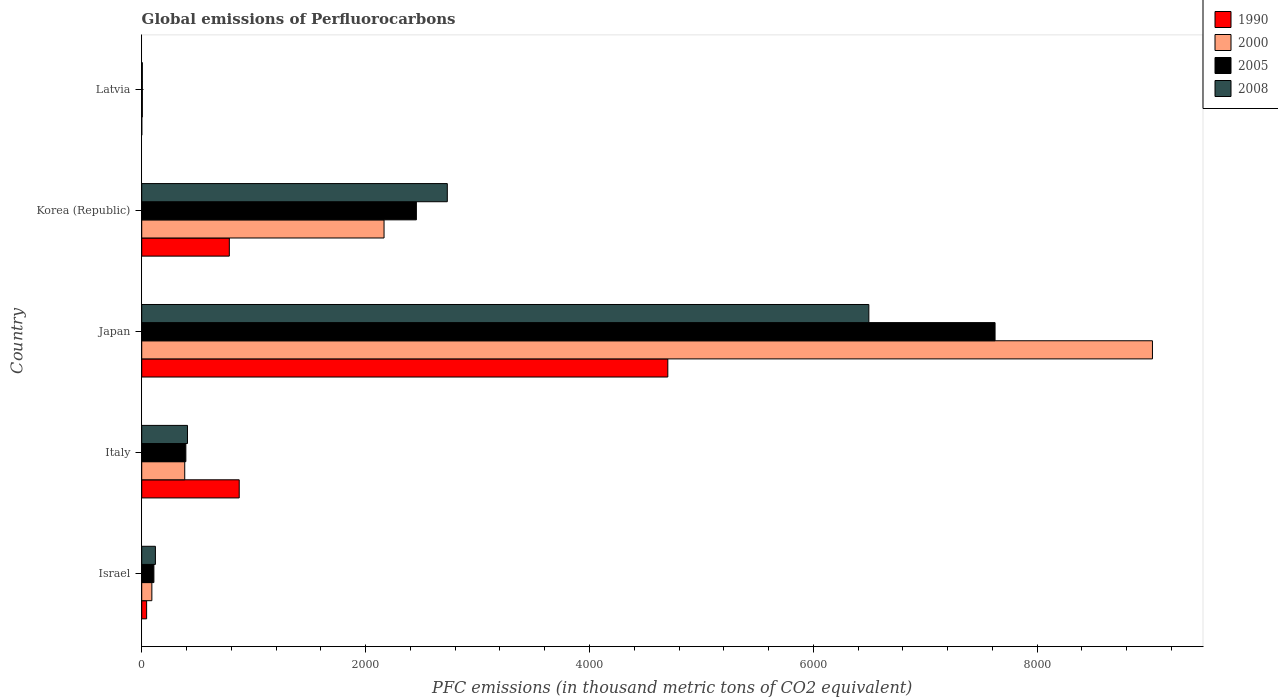How many different coloured bars are there?
Make the answer very short. 4. How many groups of bars are there?
Your answer should be very brief. 5. Are the number of bars per tick equal to the number of legend labels?
Your answer should be very brief. Yes. How many bars are there on the 3rd tick from the bottom?
Make the answer very short. 4. What is the label of the 5th group of bars from the top?
Offer a terse response. Israel. In how many cases, is the number of bars for a given country not equal to the number of legend labels?
Your response must be concise. 0. What is the global emissions of Perfluorocarbons in 2008 in Japan?
Your answer should be compact. 6496.1. Across all countries, what is the maximum global emissions of Perfluorocarbons in 2005?
Provide a succinct answer. 7623.6. Across all countries, what is the minimum global emissions of Perfluorocarbons in 2005?
Keep it short and to the point. 5.5. In which country was the global emissions of Perfluorocarbons in 1990 maximum?
Your answer should be compact. Japan. In which country was the global emissions of Perfluorocarbons in 2008 minimum?
Ensure brevity in your answer.  Latvia. What is the total global emissions of Perfluorocarbons in 1990 in the graph?
Keep it short and to the point. 6398.1. What is the difference between the global emissions of Perfluorocarbons in 2005 in Israel and that in Latvia?
Provide a short and direct response. 103.2. What is the difference between the global emissions of Perfluorocarbons in 1990 in Japan and the global emissions of Perfluorocarbons in 2008 in Italy?
Offer a terse response. 4291.2. What is the average global emissions of Perfluorocarbons in 1990 per country?
Provide a short and direct response. 1279.62. What is the difference between the global emissions of Perfluorocarbons in 2005 and global emissions of Perfluorocarbons in 1990 in Latvia?
Ensure brevity in your answer.  4.8. What is the ratio of the global emissions of Perfluorocarbons in 1990 in Israel to that in Japan?
Give a very brief answer. 0.01. Is the global emissions of Perfluorocarbons in 2005 in Israel less than that in Latvia?
Give a very brief answer. No. What is the difference between the highest and the second highest global emissions of Perfluorocarbons in 2005?
Offer a very short reply. 5169.9. What is the difference between the highest and the lowest global emissions of Perfluorocarbons in 2005?
Ensure brevity in your answer.  7618.1. Is it the case that in every country, the sum of the global emissions of Perfluorocarbons in 2008 and global emissions of Perfluorocarbons in 2000 is greater than the sum of global emissions of Perfluorocarbons in 1990 and global emissions of Perfluorocarbons in 2005?
Your answer should be very brief. No. What does the 3rd bar from the top in Latvia represents?
Provide a succinct answer. 2000. What does the 4th bar from the bottom in Italy represents?
Your response must be concise. 2008. Are the values on the major ticks of X-axis written in scientific E-notation?
Offer a terse response. No. Does the graph contain any zero values?
Make the answer very short. No. Does the graph contain grids?
Offer a very short reply. No. How are the legend labels stacked?
Ensure brevity in your answer.  Vertical. What is the title of the graph?
Your answer should be compact. Global emissions of Perfluorocarbons. Does "2004" appear as one of the legend labels in the graph?
Give a very brief answer. No. What is the label or title of the X-axis?
Offer a terse response. PFC emissions (in thousand metric tons of CO2 equivalent). What is the PFC emissions (in thousand metric tons of CO2 equivalent) in 1990 in Israel?
Provide a short and direct response. 43.8. What is the PFC emissions (in thousand metric tons of CO2 equivalent) in 2000 in Israel?
Provide a short and direct response. 90.5. What is the PFC emissions (in thousand metric tons of CO2 equivalent) of 2005 in Israel?
Keep it short and to the point. 108.7. What is the PFC emissions (in thousand metric tons of CO2 equivalent) of 2008 in Israel?
Provide a succinct answer. 122.3. What is the PFC emissions (in thousand metric tons of CO2 equivalent) in 1990 in Italy?
Make the answer very short. 871. What is the PFC emissions (in thousand metric tons of CO2 equivalent) of 2000 in Italy?
Give a very brief answer. 384.3. What is the PFC emissions (in thousand metric tons of CO2 equivalent) of 2005 in Italy?
Make the answer very short. 394.3. What is the PFC emissions (in thousand metric tons of CO2 equivalent) in 2008 in Italy?
Give a very brief answer. 408.8. What is the PFC emissions (in thousand metric tons of CO2 equivalent) of 1990 in Japan?
Provide a short and direct response. 4700. What is the PFC emissions (in thousand metric tons of CO2 equivalent) of 2000 in Japan?
Ensure brevity in your answer.  9029.8. What is the PFC emissions (in thousand metric tons of CO2 equivalent) in 2005 in Japan?
Your answer should be compact. 7623.6. What is the PFC emissions (in thousand metric tons of CO2 equivalent) in 2008 in Japan?
Provide a short and direct response. 6496.1. What is the PFC emissions (in thousand metric tons of CO2 equivalent) in 1990 in Korea (Republic)?
Offer a terse response. 782.6. What is the PFC emissions (in thousand metric tons of CO2 equivalent) of 2000 in Korea (Republic)?
Your response must be concise. 2164.9. What is the PFC emissions (in thousand metric tons of CO2 equivalent) of 2005 in Korea (Republic)?
Make the answer very short. 2453.7. What is the PFC emissions (in thousand metric tons of CO2 equivalent) in 2008 in Korea (Republic)?
Your answer should be very brief. 2730.1. What is the PFC emissions (in thousand metric tons of CO2 equivalent) of 2000 in Latvia?
Offer a very short reply. 5.7. Across all countries, what is the maximum PFC emissions (in thousand metric tons of CO2 equivalent) in 1990?
Offer a terse response. 4700. Across all countries, what is the maximum PFC emissions (in thousand metric tons of CO2 equivalent) of 2000?
Offer a very short reply. 9029.8. Across all countries, what is the maximum PFC emissions (in thousand metric tons of CO2 equivalent) in 2005?
Give a very brief answer. 7623.6. Across all countries, what is the maximum PFC emissions (in thousand metric tons of CO2 equivalent) of 2008?
Give a very brief answer. 6496.1. Across all countries, what is the minimum PFC emissions (in thousand metric tons of CO2 equivalent) of 1990?
Offer a very short reply. 0.7. Across all countries, what is the minimum PFC emissions (in thousand metric tons of CO2 equivalent) in 2000?
Ensure brevity in your answer.  5.7. Across all countries, what is the minimum PFC emissions (in thousand metric tons of CO2 equivalent) in 2005?
Keep it short and to the point. 5.5. What is the total PFC emissions (in thousand metric tons of CO2 equivalent) of 1990 in the graph?
Offer a terse response. 6398.1. What is the total PFC emissions (in thousand metric tons of CO2 equivalent) of 2000 in the graph?
Provide a succinct answer. 1.17e+04. What is the total PFC emissions (in thousand metric tons of CO2 equivalent) in 2005 in the graph?
Make the answer very short. 1.06e+04. What is the total PFC emissions (in thousand metric tons of CO2 equivalent) of 2008 in the graph?
Provide a succinct answer. 9762.8. What is the difference between the PFC emissions (in thousand metric tons of CO2 equivalent) in 1990 in Israel and that in Italy?
Provide a succinct answer. -827.2. What is the difference between the PFC emissions (in thousand metric tons of CO2 equivalent) in 2000 in Israel and that in Italy?
Your answer should be compact. -293.8. What is the difference between the PFC emissions (in thousand metric tons of CO2 equivalent) of 2005 in Israel and that in Italy?
Give a very brief answer. -285.6. What is the difference between the PFC emissions (in thousand metric tons of CO2 equivalent) of 2008 in Israel and that in Italy?
Keep it short and to the point. -286.5. What is the difference between the PFC emissions (in thousand metric tons of CO2 equivalent) of 1990 in Israel and that in Japan?
Provide a succinct answer. -4656.2. What is the difference between the PFC emissions (in thousand metric tons of CO2 equivalent) in 2000 in Israel and that in Japan?
Provide a short and direct response. -8939.3. What is the difference between the PFC emissions (in thousand metric tons of CO2 equivalent) in 2005 in Israel and that in Japan?
Offer a very short reply. -7514.9. What is the difference between the PFC emissions (in thousand metric tons of CO2 equivalent) in 2008 in Israel and that in Japan?
Give a very brief answer. -6373.8. What is the difference between the PFC emissions (in thousand metric tons of CO2 equivalent) of 1990 in Israel and that in Korea (Republic)?
Ensure brevity in your answer.  -738.8. What is the difference between the PFC emissions (in thousand metric tons of CO2 equivalent) of 2000 in Israel and that in Korea (Republic)?
Offer a very short reply. -2074.4. What is the difference between the PFC emissions (in thousand metric tons of CO2 equivalent) of 2005 in Israel and that in Korea (Republic)?
Provide a succinct answer. -2345. What is the difference between the PFC emissions (in thousand metric tons of CO2 equivalent) in 2008 in Israel and that in Korea (Republic)?
Your answer should be very brief. -2607.8. What is the difference between the PFC emissions (in thousand metric tons of CO2 equivalent) of 1990 in Israel and that in Latvia?
Your answer should be very brief. 43.1. What is the difference between the PFC emissions (in thousand metric tons of CO2 equivalent) in 2000 in Israel and that in Latvia?
Offer a terse response. 84.8. What is the difference between the PFC emissions (in thousand metric tons of CO2 equivalent) in 2005 in Israel and that in Latvia?
Your answer should be compact. 103.2. What is the difference between the PFC emissions (in thousand metric tons of CO2 equivalent) of 2008 in Israel and that in Latvia?
Give a very brief answer. 116.8. What is the difference between the PFC emissions (in thousand metric tons of CO2 equivalent) in 1990 in Italy and that in Japan?
Offer a very short reply. -3829. What is the difference between the PFC emissions (in thousand metric tons of CO2 equivalent) of 2000 in Italy and that in Japan?
Your response must be concise. -8645.5. What is the difference between the PFC emissions (in thousand metric tons of CO2 equivalent) in 2005 in Italy and that in Japan?
Give a very brief answer. -7229.3. What is the difference between the PFC emissions (in thousand metric tons of CO2 equivalent) of 2008 in Italy and that in Japan?
Offer a very short reply. -6087.3. What is the difference between the PFC emissions (in thousand metric tons of CO2 equivalent) of 1990 in Italy and that in Korea (Republic)?
Your response must be concise. 88.4. What is the difference between the PFC emissions (in thousand metric tons of CO2 equivalent) in 2000 in Italy and that in Korea (Republic)?
Your answer should be compact. -1780.6. What is the difference between the PFC emissions (in thousand metric tons of CO2 equivalent) in 2005 in Italy and that in Korea (Republic)?
Your answer should be compact. -2059.4. What is the difference between the PFC emissions (in thousand metric tons of CO2 equivalent) of 2008 in Italy and that in Korea (Republic)?
Offer a terse response. -2321.3. What is the difference between the PFC emissions (in thousand metric tons of CO2 equivalent) of 1990 in Italy and that in Latvia?
Offer a terse response. 870.3. What is the difference between the PFC emissions (in thousand metric tons of CO2 equivalent) in 2000 in Italy and that in Latvia?
Your response must be concise. 378.6. What is the difference between the PFC emissions (in thousand metric tons of CO2 equivalent) in 2005 in Italy and that in Latvia?
Offer a terse response. 388.8. What is the difference between the PFC emissions (in thousand metric tons of CO2 equivalent) of 2008 in Italy and that in Latvia?
Your response must be concise. 403.3. What is the difference between the PFC emissions (in thousand metric tons of CO2 equivalent) of 1990 in Japan and that in Korea (Republic)?
Offer a very short reply. 3917.4. What is the difference between the PFC emissions (in thousand metric tons of CO2 equivalent) of 2000 in Japan and that in Korea (Republic)?
Ensure brevity in your answer.  6864.9. What is the difference between the PFC emissions (in thousand metric tons of CO2 equivalent) of 2005 in Japan and that in Korea (Republic)?
Your response must be concise. 5169.9. What is the difference between the PFC emissions (in thousand metric tons of CO2 equivalent) in 2008 in Japan and that in Korea (Republic)?
Offer a terse response. 3766. What is the difference between the PFC emissions (in thousand metric tons of CO2 equivalent) in 1990 in Japan and that in Latvia?
Make the answer very short. 4699.3. What is the difference between the PFC emissions (in thousand metric tons of CO2 equivalent) of 2000 in Japan and that in Latvia?
Ensure brevity in your answer.  9024.1. What is the difference between the PFC emissions (in thousand metric tons of CO2 equivalent) of 2005 in Japan and that in Latvia?
Give a very brief answer. 7618.1. What is the difference between the PFC emissions (in thousand metric tons of CO2 equivalent) of 2008 in Japan and that in Latvia?
Make the answer very short. 6490.6. What is the difference between the PFC emissions (in thousand metric tons of CO2 equivalent) in 1990 in Korea (Republic) and that in Latvia?
Offer a terse response. 781.9. What is the difference between the PFC emissions (in thousand metric tons of CO2 equivalent) in 2000 in Korea (Republic) and that in Latvia?
Offer a very short reply. 2159.2. What is the difference between the PFC emissions (in thousand metric tons of CO2 equivalent) of 2005 in Korea (Republic) and that in Latvia?
Offer a terse response. 2448.2. What is the difference between the PFC emissions (in thousand metric tons of CO2 equivalent) of 2008 in Korea (Republic) and that in Latvia?
Provide a succinct answer. 2724.6. What is the difference between the PFC emissions (in thousand metric tons of CO2 equivalent) in 1990 in Israel and the PFC emissions (in thousand metric tons of CO2 equivalent) in 2000 in Italy?
Provide a short and direct response. -340.5. What is the difference between the PFC emissions (in thousand metric tons of CO2 equivalent) in 1990 in Israel and the PFC emissions (in thousand metric tons of CO2 equivalent) in 2005 in Italy?
Keep it short and to the point. -350.5. What is the difference between the PFC emissions (in thousand metric tons of CO2 equivalent) of 1990 in Israel and the PFC emissions (in thousand metric tons of CO2 equivalent) of 2008 in Italy?
Provide a succinct answer. -365. What is the difference between the PFC emissions (in thousand metric tons of CO2 equivalent) of 2000 in Israel and the PFC emissions (in thousand metric tons of CO2 equivalent) of 2005 in Italy?
Ensure brevity in your answer.  -303.8. What is the difference between the PFC emissions (in thousand metric tons of CO2 equivalent) of 2000 in Israel and the PFC emissions (in thousand metric tons of CO2 equivalent) of 2008 in Italy?
Provide a short and direct response. -318.3. What is the difference between the PFC emissions (in thousand metric tons of CO2 equivalent) of 2005 in Israel and the PFC emissions (in thousand metric tons of CO2 equivalent) of 2008 in Italy?
Your answer should be very brief. -300.1. What is the difference between the PFC emissions (in thousand metric tons of CO2 equivalent) in 1990 in Israel and the PFC emissions (in thousand metric tons of CO2 equivalent) in 2000 in Japan?
Your answer should be very brief. -8986. What is the difference between the PFC emissions (in thousand metric tons of CO2 equivalent) in 1990 in Israel and the PFC emissions (in thousand metric tons of CO2 equivalent) in 2005 in Japan?
Ensure brevity in your answer.  -7579.8. What is the difference between the PFC emissions (in thousand metric tons of CO2 equivalent) of 1990 in Israel and the PFC emissions (in thousand metric tons of CO2 equivalent) of 2008 in Japan?
Your answer should be compact. -6452.3. What is the difference between the PFC emissions (in thousand metric tons of CO2 equivalent) in 2000 in Israel and the PFC emissions (in thousand metric tons of CO2 equivalent) in 2005 in Japan?
Offer a terse response. -7533.1. What is the difference between the PFC emissions (in thousand metric tons of CO2 equivalent) of 2000 in Israel and the PFC emissions (in thousand metric tons of CO2 equivalent) of 2008 in Japan?
Provide a short and direct response. -6405.6. What is the difference between the PFC emissions (in thousand metric tons of CO2 equivalent) of 2005 in Israel and the PFC emissions (in thousand metric tons of CO2 equivalent) of 2008 in Japan?
Provide a short and direct response. -6387.4. What is the difference between the PFC emissions (in thousand metric tons of CO2 equivalent) in 1990 in Israel and the PFC emissions (in thousand metric tons of CO2 equivalent) in 2000 in Korea (Republic)?
Your response must be concise. -2121.1. What is the difference between the PFC emissions (in thousand metric tons of CO2 equivalent) of 1990 in Israel and the PFC emissions (in thousand metric tons of CO2 equivalent) of 2005 in Korea (Republic)?
Offer a very short reply. -2409.9. What is the difference between the PFC emissions (in thousand metric tons of CO2 equivalent) in 1990 in Israel and the PFC emissions (in thousand metric tons of CO2 equivalent) in 2008 in Korea (Republic)?
Give a very brief answer. -2686.3. What is the difference between the PFC emissions (in thousand metric tons of CO2 equivalent) of 2000 in Israel and the PFC emissions (in thousand metric tons of CO2 equivalent) of 2005 in Korea (Republic)?
Keep it short and to the point. -2363.2. What is the difference between the PFC emissions (in thousand metric tons of CO2 equivalent) of 2000 in Israel and the PFC emissions (in thousand metric tons of CO2 equivalent) of 2008 in Korea (Republic)?
Offer a very short reply. -2639.6. What is the difference between the PFC emissions (in thousand metric tons of CO2 equivalent) in 2005 in Israel and the PFC emissions (in thousand metric tons of CO2 equivalent) in 2008 in Korea (Republic)?
Your answer should be very brief. -2621.4. What is the difference between the PFC emissions (in thousand metric tons of CO2 equivalent) of 1990 in Israel and the PFC emissions (in thousand metric tons of CO2 equivalent) of 2000 in Latvia?
Keep it short and to the point. 38.1. What is the difference between the PFC emissions (in thousand metric tons of CO2 equivalent) in 1990 in Israel and the PFC emissions (in thousand metric tons of CO2 equivalent) in 2005 in Latvia?
Provide a short and direct response. 38.3. What is the difference between the PFC emissions (in thousand metric tons of CO2 equivalent) of 1990 in Israel and the PFC emissions (in thousand metric tons of CO2 equivalent) of 2008 in Latvia?
Keep it short and to the point. 38.3. What is the difference between the PFC emissions (in thousand metric tons of CO2 equivalent) of 2005 in Israel and the PFC emissions (in thousand metric tons of CO2 equivalent) of 2008 in Latvia?
Your answer should be compact. 103.2. What is the difference between the PFC emissions (in thousand metric tons of CO2 equivalent) of 1990 in Italy and the PFC emissions (in thousand metric tons of CO2 equivalent) of 2000 in Japan?
Offer a terse response. -8158.8. What is the difference between the PFC emissions (in thousand metric tons of CO2 equivalent) in 1990 in Italy and the PFC emissions (in thousand metric tons of CO2 equivalent) in 2005 in Japan?
Your answer should be very brief. -6752.6. What is the difference between the PFC emissions (in thousand metric tons of CO2 equivalent) of 1990 in Italy and the PFC emissions (in thousand metric tons of CO2 equivalent) of 2008 in Japan?
Give a very brief answer. -5625.1. What is the difference between the PFC emissions (in thousand metric tons of CO2 equivalent) in 2000 in Italy and the PFC emissions (in thousand metric tons of CO2 equivalent) in 2005 in Japan?
Ensure brevity in your answer.  -7239.3. What is the difference between the PFC emissions (in thousand metric tons of CO2 equivalent) in 2000 in Italy and the PFC emissions (in thousand metric tons of CO2 equivalent) in 2008 in Japan?
Offer a very short reply. -6111.8. What is the difference between the PFC emissions (in thousand metric tons of CO2 equivalent) in 2005 in Italy and the PFC emissions (in thousand metric tons of CO2 equivalent) in 2008 in Japan?
Offer a very short reply. -6101.8. What is the difference between the PFC emissions (in thousand metric tons of CO2 equivalent) of 1990 in Italy and the PFC emissions (in thousand metric tons of CO2 equivalent) of 2000 in Korea (Republic)?
Keep it short and to the point. -1293.9. What is the difference between the PFC emissions (in thousand metric tons of CO2 equivalent) in 1990 in Italy and the PFC emissions (in thousand metric tons of CO2 equivalent) in 2005 in Korea (Republic)?
Keep it short and to the point. -1582.7. What is the difference between the PFC emissions (in thousand metric tons of CO2 equivalent) of 1990 in Italy and the PFC emissions (in thousand metric tons of CO2 equivalent) of 2008 in Korea (Republic)?
Keep it short and to the point. -1859.1. What is the difference between the PFC emissions (in thousand metric tons of CO2 equivalent) of 2000 in Italy and the PFC emissions (in thousand metric tons of CO2 equivalent) of 2005 in Korea (Republic)?
Ensure brevity in your answer.  -2069.4. What is the difference between the PFC emissions (in thousand metric tons of CO2 equivalent) of 2000 in Italy and the PFC emissions (in thousand metric tons of CO2 equivalent) of 2008 in Korea (Republic)?
Ensure brevity in your answer.  -2345.8. What is the difference between the PFC emissions (in thousand metric tons of CO2 equivalent) of 2005 in Italy and the PFC emissions (in thousand metric tons of CO2 equivalent) of 2008 in Korea (Republic)?
Provide a short and direct response. -2335.8. What is the difference between the PFC emissions (in thousand metric tons of CO2 equivalent) of 1990 in Italy and the PFC emissions (in thousand metric tons of CO2 equivalent) of 2000 in Latvia?
Provide a short and direct response. 865.3. What is the difference between the PFC emissions (in thousand metric tons of CO2 equivalent) of 1990 in Italy and the PFC emissions (in thousand metric tons of CO2 equivalent) of 2005 in Latvia?
Offer a very short reply. 865.5. What is the difference between the PFC emissions (in thousand metric tons of CO2 equivalent) of 1990 in Italy and the PFC emissions (in thousand metric tons of CO2 equivalent) of 2008 in Latvia?
Give a very brief answer. 865.5. What is the difference between the PFC emissions (in thousand metric tons of CO2 equivalent) in 2000 in Italy and the PFC emissions (in thousand metric tons of CO2 equivalent) in 2005 in Latvia?
Offer a very short reply. 378.8. What is the difference between the PFC emissions (in thousand metric tons of CO2 equivalent) of 2000 in Italy and the PFC emissions (in thousand metric tons of CO2 equivalent) of 2008 in Latvia?
Offer a very short reply. 378.8. What is the difference between the PFC emissions (in thousand metric tons of CO2 equivalent) in 2005 in Italy and the PFC emissions (in thousand metric tons of CO2 equivalent) in 2008 in Latvia?
Offer a terse response. 388.8. What is the difference between the PFC emissions (in thousand metric tons of CO2 equivalent) in 1990 in Japan and the PFC emissions (in thousand metric tons of CO2 equivalent) in 2000 in Korea (Republic)?
Keep it short and to the point. 2535.1. What is the difference between the PFC emissions (in thousand metric tons of CO2 equivalent) of 1990 in Japan and the PFC emissions (in thousand metric tons of CO2 equivalent) of 2005 in Korea (Republic)?
Give a very brief answer. 2246.3. What is the difference between the PFC emissions (in thousand metric tons of CO2 equivalent) in 1990 in Japan and the PFC emissions (in thousand metric tons of CO2 equivalent) in 2008 in Korea (Republic)?
Offer a terse response. 1969.9. What is the difference between the PFC emissions (in thousand metric tons of CO2 equivalent) in 2000 in Japan and the PFC emissions (in thousand metric tons of CO2 equivalent) in 2005 in Korea (Republic)?
Your response must be concise. 6576.1. What is the difference between the PFC emissions (in thousand metric tons of CO2 equivalent) of 2000 in Japan and the PFC emissions (in thousand metric tons of CO2 equivalent) of 2008 in Korea (Republic)?
Give a very brief answer. 6299.7. What is the difference between the PFC emissions (in thousand metric tons of CO2 equivalent) of 2005 in Japan and the PFC emissions (in thousand metric tons of CO2 equivalent) of 2008 in Korea (Republic)?
Provide a short and direct response. 4893.5. What is the difference between the PFC emissions (in thousand metric tons of CO2 equivalent) in 1990 in Japan and the PFC emissions (in thousand metric tons of CO2 equivalent) in 2000 in Latvia?
Your response must be concise. 4694.3. What is the difference between the PFC emissions (in thousand metric tons of CO2 equivalent) of 1990 in Japan and the PFC emissions (in thousand metric tons of CO2 equivalent) of 2005 in Latvia?
Your answer should be compact. 4694.5. What is the difference between the PFC emissions (in thousand metric tons of CO2 equivalent) of 1990 in Japan and the PFC emissions (in thousand metric tons of CO2 equivalent) of 2008 in Latvia?
Make the answer very short. 4694.5. What is the difference between the PFC emissions (in thousand metric tons of CO2 equivalent) of 2000 in Japan and the PFC emissions (in thousand metric tons of CO2 equivalent) of 2005 in Latvia?
Your answer should be compact. 9024.3. What is the difference between the PFC emissions (in thousand metric tons of CO2 equivalent) of 2000 in Japan and the PFC emissions (in thousand metric tons of CO2 equivalent) of 2008 in Latvia?
Offer a terse response. 9024.3. What is the difference between the PFC emissions (in thousand metric tons of CO2 equivalent) in 2005 in Japan and the PFC emissions (in thousand metric tons of CO2 equivalent) in 2008 in Latvia?
Your response must be concise. 7618.1. What is the difference between the PFC emissions (in thousand metric tons of CO2 equivalent) of 1990 in Korea (Republic) and the PFC emissions (in thousand metric tons of CO2 equivalent) of 2000 in Latvia?
Provide a succinct answer. 776.9. What is the difference between the PFC emissions (in thousand metric tons of CO2 equivalent) in 1990 in Korea (Republic) and the PFC emissions (in thousand metric tons of CO2 equivalent) in 2005 in Latvia?
Make the answer very short. 777.1. What is the difference between the PFC emissions (in thousand metric tons of CO2 equivalent) of 1990 in Korea (Republic) and the PFC emissions (in thousand metric tons of CO2 equivalent) of 2008 in Latvia?
Provide a short and direct response. 777.1. What is the difference between the PFC emissions (in thousand metric tons of CO2 equivalent) in 2000 in Korea (Republic) and the PFC emissions (in thousand metric tons of CO2 equivalent) in 2005 in Latvia?
Make the answer very short. 2159.4. What is the difference between the PFC emissions (in thousand metric tons of CO2 equivalent) in 2000 in Korea (Republic) and the PFC emissions (in thousand metric tons of CO2 equivalent) in 2008 in Latvia?
Provide a short and direct response. 2159.4. What is the difference between the PFC emissions (in thousand metric tons of CO2 equivalent) of 2005 in Korea (Republic) and the PFC emissions (in thousand metric tons of CO2 equivalent) of 2008 in Latvia?
Make the answer very short. 2448.2. What is the average PFC emissions (in thousand metric tons of CO2 equivalent) in 1990 per country?
Provide a short and direct response. 1279.62. What is the average PFC emissions (in thousand metric tons of CO2 equivalent) in 2000 per country?
Provide a succinct answer. 2335.04. What is the average PFC emissions (in thousand metric tons of CO2 equivalent) of 2005 per country?
Provide a succinct answer. 2117.16. What is the average PFC emissions (in thousand metric tons of CO2 equivalent) in 2008 per country?
Keep it short and to the point. 1952.56. What is the difference between the PFC emissions (in thousand metric tons of CO2 equivalent) of 1990 and PFC emissions (in thousand metric tons of CO2 equivalent) of 2000 in Israel?
Give a very brief answer. -46.7. What is the difference between the PFC emissions (in thousand metric tons of CO2 equivalent) in 1990 and PFC emissions (in thousand metric tons of CO2 equivalent) in 2005 in Israel?
Give a very brief answer. -64.9. What is the difference between the PFC emissions (in thousand metric tons of CO2 equivalent) of 1990 and PFC emissions (in thousand metric tons of CO2 equivalent) of 2008 in Israel?
Offer a terse response. -78.5. What is the difference between the PFC emissions (in thousand metric tons of CO2 equivalent) of 2000 and PFC emissions (in thousand metric tons of CO2 equivalent) of 2005 in Israel?
Provide a short and direct response. -18.2. What is the difference between the PFC emissions (in thousand metric tons of CO2 equivalent) in 2000 and PFC emissions (in thousand metric tons of CO2 equivalent) in 2008 in Israel?
Make the answer very short. -31.8. What is the difference between the PFC emissions (in thousand metric tons of CO2 equivalent) of 2005 and PFC emissions (in thousand metric tons of CO2 equivalent) of 2008 in Israel?
Keep it short and to the point. -13.6. What is the difference between the PFC emissions (in thousand metric tons of CO2 equivalent) of 1990 and PFC emissions (in thousand metric tons of CO2 equivalent) of 2000 in Italy?
Keep it short and to the point. 486.7. What is the difference between the PFC emissions (in thousand metric tons of CO2 equivalent) in 1990 and PFC emissions (in thousand metric tons of CO2 equivalent) in 2005 in Italy?
Give a very brief answer. 476.7. What is the difference between the PFC emissions (in thousand metric tons of CO2 equivalent) in 1990 and PFC emissions (in thousand metric tons of CO2 equivalent) in 2008 in Italy?
Offer a terse response. 462.2. What is the difference between the PFC emissions (in thousand metric tons of CO2 equivalent) of 2000 and PFC emissions (in thousand metric tons of CO2 equivalent) of 2008 in Italy?
Your answer should be compact. -24.5. What is the difference between the PFC emissions (in thousand metric tons of CO2 equivalent) of 2005 and PFC emissions (in thousand metric tons of CO2 equivalent) of 2008 in Italy?
Your answer should be compact. -14.5. What is the difference between the PFC emissions (in thousand metric tons of CO2 equivalent) in 1990 and PFC emissions (in thousand metric tons of CO2 equivalent) in 2000 in Japan?
Your response must be concise. -4329.8. What is the difference between the PFC emissions (in thousand metric tons of CO2 equivalent) of 1990 and PFC emissions (in thousand metric tons of CO2 equivalent) of 2005 in Japan?
Your answer should be compact. -2923.6. What is the difference between the PFC emissions (in thousand metric tons of CO2 equivalent) in 1990 and PFC emissions (in thousand metric tons of CO2 equivalent) in 2008 in Japan?
Your answer should be compact. -1796.1. What is the difference between the PFC emissions (in thousand metric tons of CO2 equivalent) of 2000 and PFC emissions (in thousand metric tons of CO2 equivalent) of 2005 in Japan?
Your answer should be very brief. 1406.2. What is the difference between the PFC emissions (in thousand metric tons of CO2 equivalent) in 2000 and PFC emissions (in thousand metric tons of CO2 equivalent) in 2008 in Japan?
Your answer should be very brief. 2533.7. What is the difference between the PFC emissions (in thousand metric tons of CO2 equivalent) in 2005 and PFC emissions (in thousand metric tons of CO2 equivalent) in 2008 in Japan?
Keep it short and to the point. 1127.5. What is the difference between the PFC emissions (in thousand metric tons of CO2 equivalent) in 1990 and PFC emissions (in thousand metric tons of CO2 equivalent) in 2000 in Korea (Republic)?
Ensure brevity in your answer.  -1382.3. What is the difference between the PFC emissions (in thousand metric tons of CO2 equivalent) of 1990 and PFC emissions (in thousand metric tons of CO2 equivalent) of 2005 in Korea (Republic)?
Ensure brevity in your answer.  -1671.1. What is the difference between the PFC emissions (in thousand metric tons of CO2 equivalent) in 1990 and PFC emissions (in thousand metric tons of CO2 equivalent) in 2008 in Korea (Republic)?
Provide a short and direct response. -1947.5. What is the difference between the PFC emissions (in thousand metric tons of CO2 equivalent) of 2000 and PFC emissions (in thousand metric tons of CO2 equivalent) of 2005 in Korea (Republic)?
Make the answer very short. -288.8. What is the difference between the PFC emissions (in thousand metric tons of CO2 equivalent) in 2000 and PFC emissions (in thousand metric tons of CO2 equivalent) in 2008 in Korea (Republic)?
Your answer should be very brief. -565.2. What is the difference between the PFC emissions (in thousand metric tons of CO2 equivalent) of 2005 and PFC emissions (in thousand metric tons of CO2 equivalent) of 2008 in Korea (Republic)?
Give a very brief answer. -276.4. What is the difference between the PFC emissions (in thousand metric tons of CO2 equivalent) in 1990 and PFC emissions (in thousand metric tons of CO2 equivalent) in 2000 in Latvia?
Your response must be concise. -5. What is the difference between the PFC emissions (in thousand metric tons of CO2 equivalent) in 1990 and PFC emissions (in thousand metric tons of CO2 equivalent) in 2005 in Latvia?
Give a very brief answer. -4.8. What is the difference between the PFC emissions (in thousand metric tons of CO2 equivalent) of 1990 and PFC emissions (in thousand metric tons of CO2 equivalent) of 2008 in Latvia?
Make the answer very short. -4.8. What is the difference between the PFC emissions (in thousand metric tons of CO2 equivalent) in 2005 and PFC emissions (in thousand metric tons of CO2 equivalent) in 2008 in Latvia?
Ensure brevity in your answer.  0. What is the ratio of the PFC emissions (in thousand metric tons of CO2 equivalent) in 1990 in Israel to that in Italy?
Your answer should be compact. 0.05. What is the ratio of the PFC emissions (in thousand metric tons of CO2 equivalent) of 2000 in Israel to that in Italy?
Offer a very short reply. 0.24. What is the ratio of the PFC emissions (in thousand metric tons of CO2 equivalent) of 2005 in Israel to that in Italy?
Your answer should be very brief. 0.28. What is the ratio of the PFC emissions (in thousand metric tons of CO2 equivalent) in 2008 in Israel to that in Italy?
Provide a short and direct response. 0.3. What is the ratio of the PFC emissions (in thousand metric tons of CO2 equivalent) of 1990 in Israel to that in Japan?
Your answer should be very brief. 0.01. What is the ratio of the PFC emissions (in thousand metric tons of CO2 equivalent) in 2005 in Israel to that in Japan?
Provide a short and direct response. 0.01. What is the ratio of the PFC emissions (in thousand metric tons of CO2 equivalent) of 2008 in Israel to that in Japan?
Provide a succinct answer. 0.02. What is the ratio of the PFC emissions (in thousand metric tons of CO2 equivalent) of 1990 in Israel to that in Korea (Republic)?
Make the answer very short. 0.06. What is the ratio of the PFC emissions (in thousand metric tons of CO2 equivalent) in 2000 in Israel to that in Korea (Republic)?
Provide a succinct answer. 0.04. What is the ratio of the PFC emissions (in thousand metric tons of CO2 equivalent) of 2005 in Israel to that in Korea (Republic)?
Give a very brief answer. 0.04. What is the ratio of the PFC emissions (in thousand metric tons of CO2 equivalent) of 2008 in Israel to that in Korea (Republic)?
Offer a terse response. 0.04. What is the ratio of the PFC emissions (in thousand metric tons of CO2 equivalent) in 1990 in Israel to that in Latvia?
Provide a short and direct response. 62.57. What is the ratio of the PFC emissions (in thousand metric tons of CO2 equivalent) in 2000 in Israel to that in Latvia?
Give a very brief answer. 15.88. What is the ratio of the PFC emissions (in thousand metric tons of CO2 equivalent) in 2005 in Israel to that in Latvia?
Your answer should be very brief. 19.76. What is the ratio of the PFC emissions (in thousand metric tons of CO2 equivalent) of 2008 in Israel to that in Latvia?
Provide a succinct answer. 22.24. What is the ratio of the PFC emissions (in thousand metric tons of CO2 equivalent) in 1990 in Italy to that in Japan?
Your answer should be compact. 0.19. What is the ratio of the PFC emissions (in thousand metric tons of CO2 equivalent) of 2000 in Italy to that in Japan?
Ensure brevity in your answer.  0.04. What is the ratio of the PFC emissions (in thousand metric tons of CO2 equivalent) of 2005 in Italy to that in Japan?
Provide a short and direct response. 0.05. What is the ratio of the PFC emissions (in thousand metric tons of CO2 equivalent) of 2008 in Italy to that in Japan?
Provide a succinct answer. 0.06. What is the ratio of the PFC emissions (in thousand metric tons of CO2 equivalent) of 1990 in Italy to that in Korea (Republic)?
Make the answer very short. 1.11. What is the ratio of the PFC emissions (in thousand metric tons of CO2 equivalent) in 2000 in Italy to that in Korea (Republic)?
Provide a short and direct response. 0.18. What is the ratio of the PFC emissions (in thousand metric tons of CO2 equivalent) in 2005 in Italy to that in Korea (Republic)?
Your answer should be very brief. 0.16. What is the ratio of the PFC emissions (in thousand metric tons of CO2 equivalent) in 2008 in Italy to that in Korea (Republic)?
Your answer should be compact. 0.15. What is the ratio of the PFC emissions (in thousand metric tons of CO2 equivalent) in 1990 in Italy to that in Latvia?
Ensure brevity in your answer.  1244.29. What is the ratio of the PFC emissions (in thousand metric tons of CO2 equivalent) of 2000 in Italy to that in Latvia?
Give a very brief answer. 67.42. What is the ratio of the PFC emissions (in thousand metric tons of CO2 equivalent) of 2005 in Italy to that in Latvia?
Make the answer very short. 71.69. What is the ratio of the PFC emissions (in thousand metric tons of CO2 equivalent) in 2008 in Italy to that in Latvia?
Your answer should be compact. 74.33. What is the ratio of the PFC emissions (in thousand metric tons of CO2 equivalent) of 1990 in Japan to that in Korea (Republic)?
Give a very brief answer. 6.01. What is the ratio of the PFC emissions (in thousand metric tons of CO2 equivalent) of 2000 in Japan to that in Korea (Republic)?
Make the answer very short. 4.17. What is the ratio of the PFC emissions (in thousand metric tons of CO2 equivalent) in 2005 in Japan to that in Korea (Republic)?
Provide a short and direct response. 3.11. What is the ratio of the PFC emissions (in thousand metric tons of CO2 equivalent) in 2008 in Japan to that in Korea (Republic)?
Keep it short and to the point. 2.38. What is the ratio of the PFC emissions (in thousand metric tons of CO2 equivalent) of 1990 in Japan to that in Latvia?
Give a very brief answer. 6714.29. What is the ratio of the PFC emissions (in thousand metric tons of CO2 equivalent) in 2000 in Japan to that in Latvia?
Make the answer very short. 1584.18. What is the ratio of the PFC emissions (in thousand metric tons of CO2 equivalent) in 2005 in Japan to that in Latvia?
Give a very brief answer. 1386.11. What is the ratio of the PFC emissions (in thousand metric tons of CO2 equivalent) in 2008 in Japan to that in Latvia?
Keep it short and to the point. 1181.11. What is the ratio of the PFC emissions (in thousand metric tons of CO2 equivalent) in 1990 in Korea (Republic) to that in Latvia?
Offer a very short reply. 1118. What is the ratio of the PFC emissions (in thousand metric tons of CO2 equivalent) of 2000 in Korea (Republic) to that in Latvia?
Offer a terse response. 379.81. What is the ratio of the PFC emissions (in thousand metric tons of CO2 equivalent) of 2005 in Korea (Republic) to that in Latvia?
Your response must be concise. 446.13. What is the ratio of the PFC emissions (in thousand metric tons of CO2 equivalent) in 2008 in Korea (Republic) to that in Latvia?
Your answer should be compact. 496.38. What is the difference between the highest and the second highest PFC emissions (in thousand metric tons of CO2 equivalent) in 1990?
Your response must be concise. 3829. What is the difference between the highest and the second highest PFC emissions (in thousand metric tons of CO2 equivalent) in 2000?
Give a very brief answer. 6864.9. What is the difference between the highest and the second highest PFC emissions (in thousand metric tons of CO2 equivalent) of 2005?
Your answer should be very brief. 5169.9. What is the difference between the highest and the second highest PFC emissions (in thousand metric tons of CO2 equivalent) of 2008?
Keep it short and to the point. 3766. What is the difference between the highest and the lowest PFC emissions (in thousand metric tons of CO2 equivalent) of 1990?
Give a very brief answer. 4699.3. What is the difference between the highest and the lowest PFC emissions (in thousand metric tons of CO2 equivalent) in 2000?
Your answer should be compact. 9024.1. What is the difference between the highest and the lowest PFC emissions (in thousand metric tons of CO2 equivalent) in 2005?
Offer a very short reply. 7618.1. What is the difference between the highest and the lowest PFC emissions (in thousand metric tons of CO2 equivalent) of 2008?
Your answer should be compact. 6490.6. 